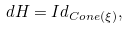Convert formula to latex. <formula><loc_0><loc_0><loc_500><loc_500>d H = I d _ { C o n e ( \xi ) } ,</formula> 